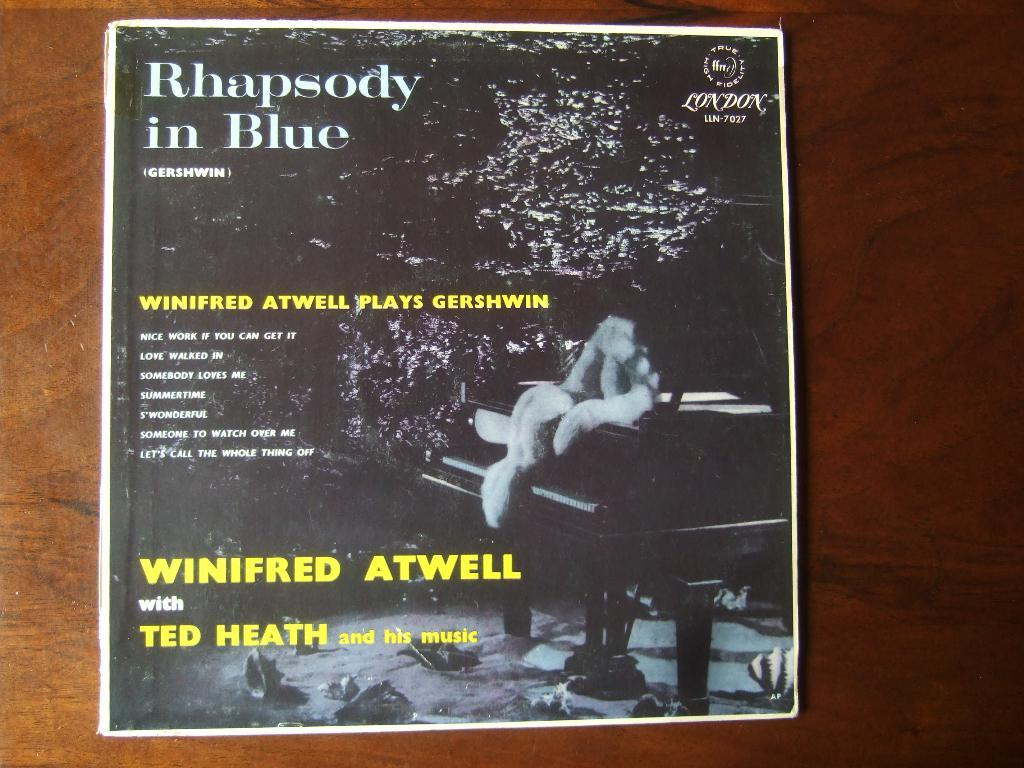<image>
Describe the image concisely. The album being show is titled Rhapsody in Blue and features Winifred Atwell with Ted Heath and his music. 